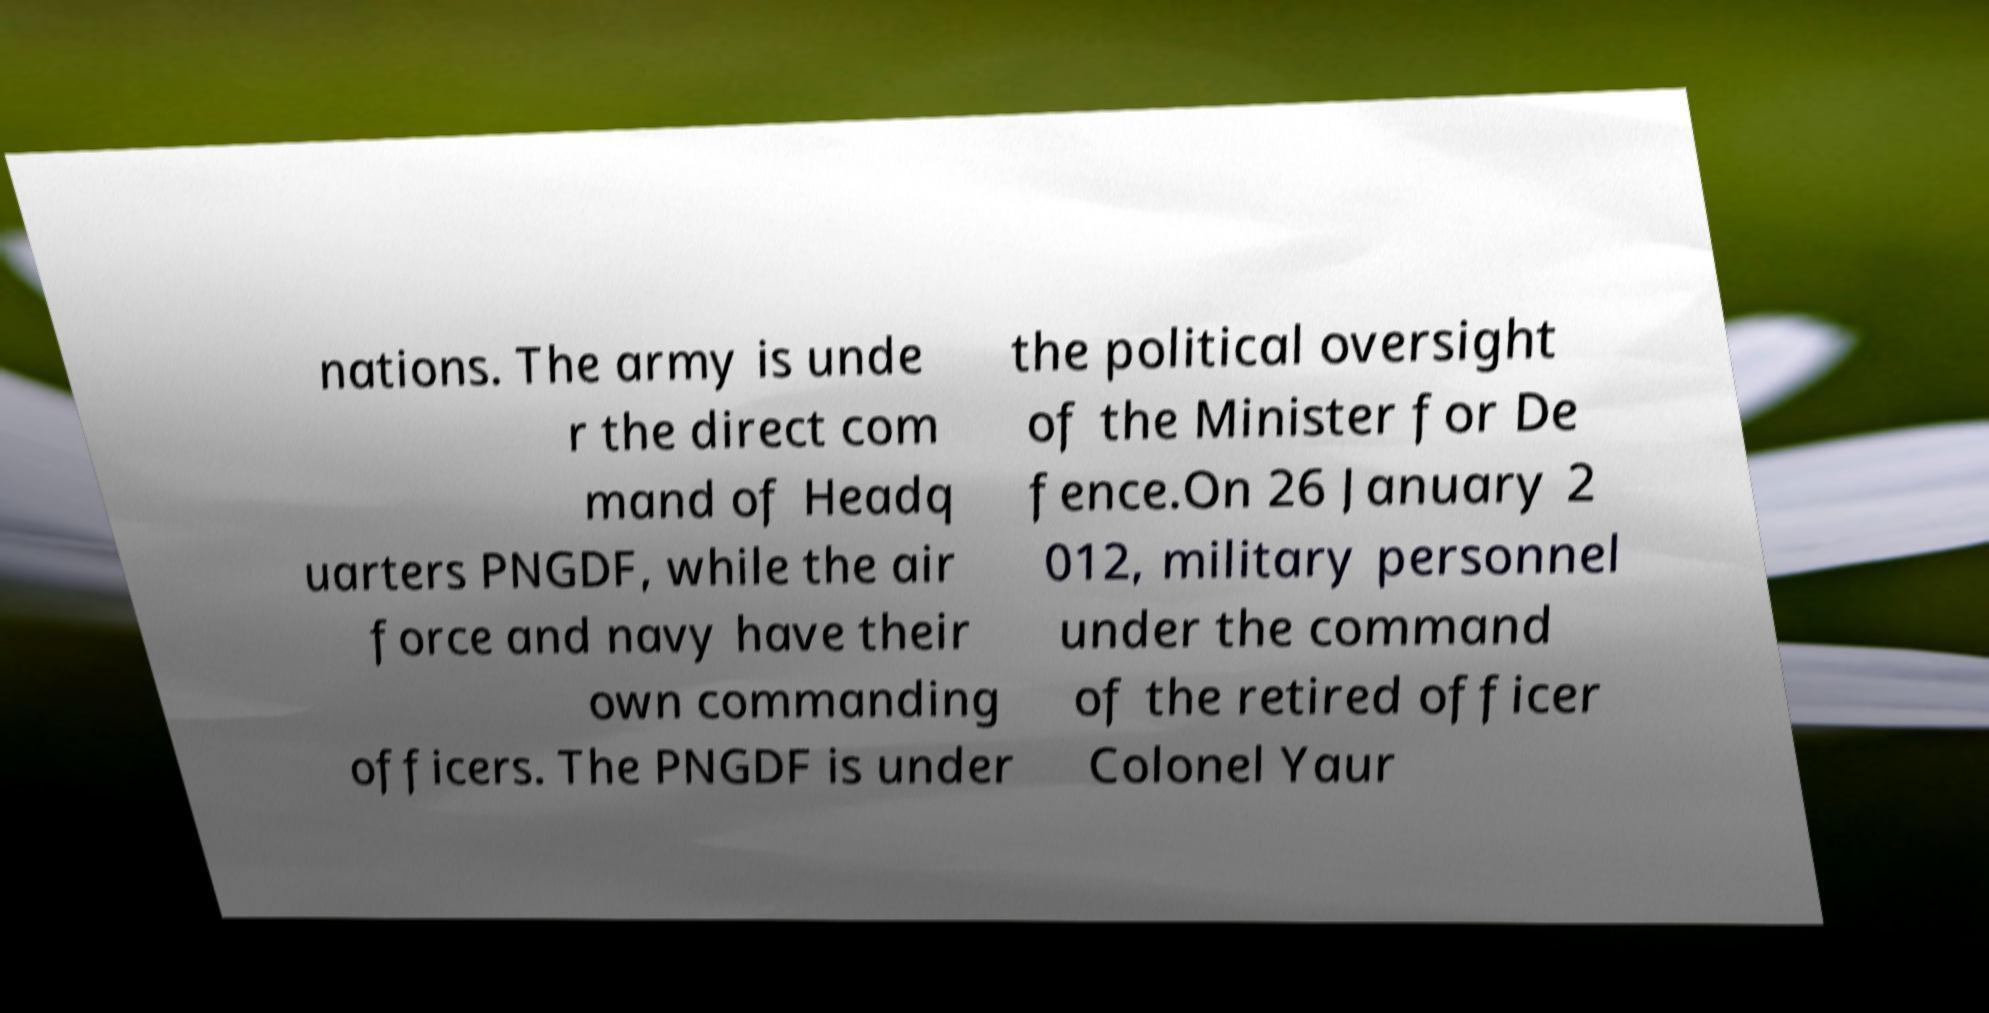Could you extract and type out the text from this image? nations. The army is unde r the direct com mand of Headq uarters PNGDF, while the air force and navy have their own commanding officers. The PNGDF is under the political oversight of the Minister for De fence.On 26 January 2 012, military personnel under the command of the retired officer Colonel Yaur 